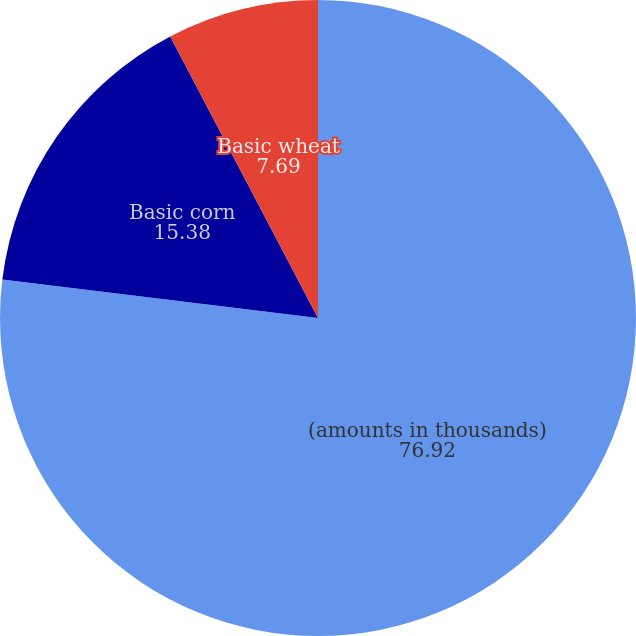Convert chart. <chart><loc_0><loc_0><loc_500><loc_500><pie_chart><fcel>(amounts in thousands)<fcel>Basic corn<fcel>Basic soybean<fcel>Basic wheat<nl><fcel>76.92%<fcel>15.38%<fcel>0.0%<fcel>7.69%<nl></chart> 